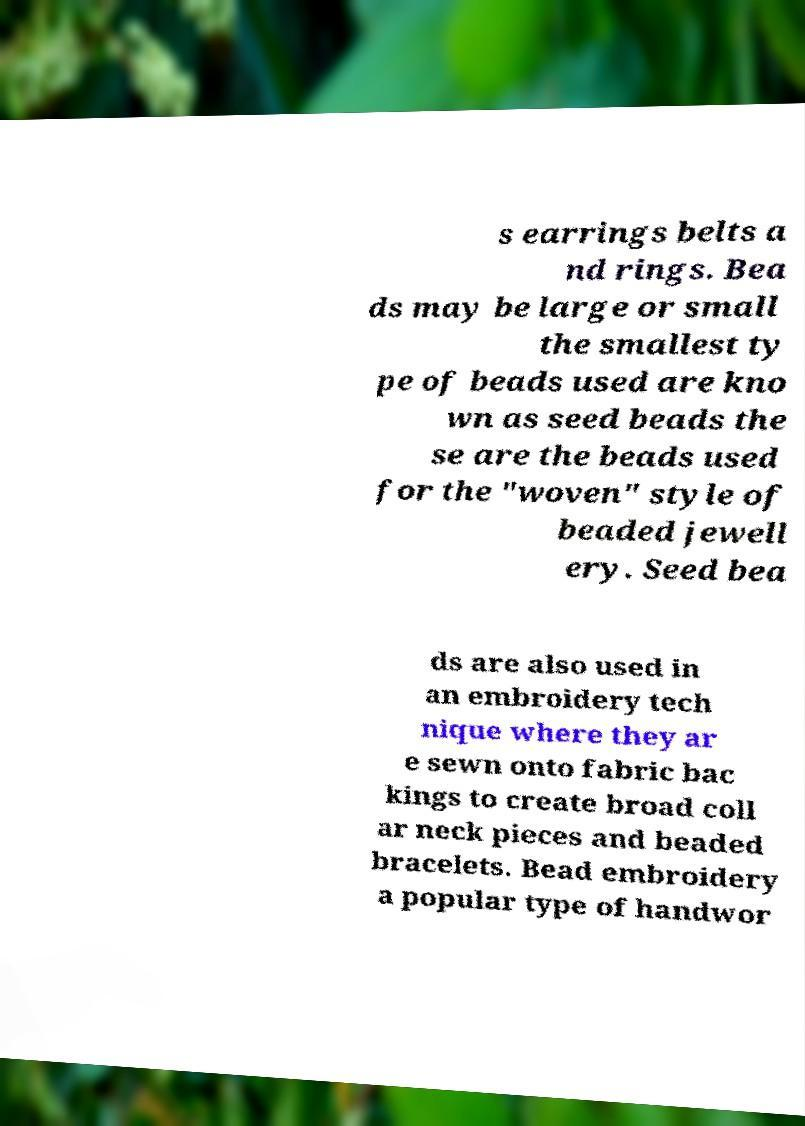I need the written content from this picture converted into text. Can you do that? s earrings belts a nd rings. Bea ds may be large or small the smallest ty pe of beads used are kno wn as seed beads the se are the beads used for the "woven" style of beaded jewell ery. Seed bea ds are also used in an embroidery tech nique where they ar e sewn onto fabric bac kings to create broad coll ar neck pieces and beaded bracelets. Bead embroidery a popular type of handwor 